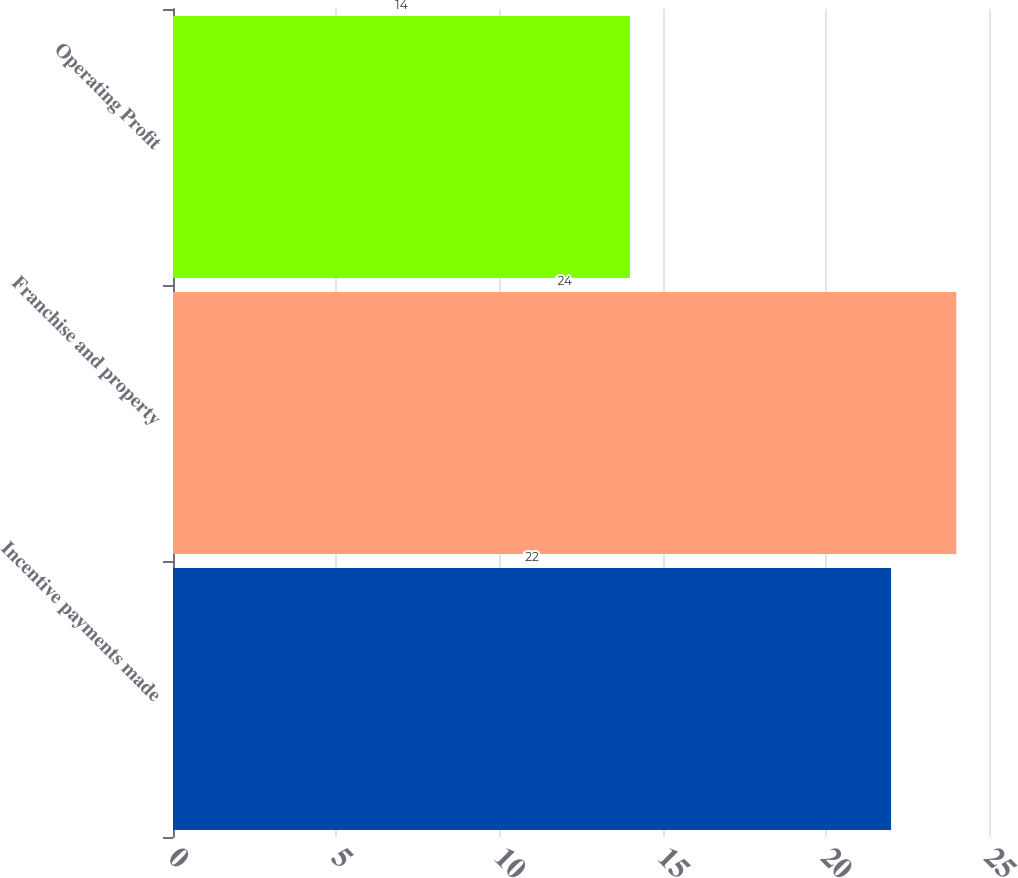Convert chart. <chart><loc_0><loc_0><loc_500><loc_500><bar_chart><fcel>Incentive payments made<fcel>Franchise and property<fcel>Operating Profit<nl><fcel>22<fcel>24<fcel>14<nl></chart> 